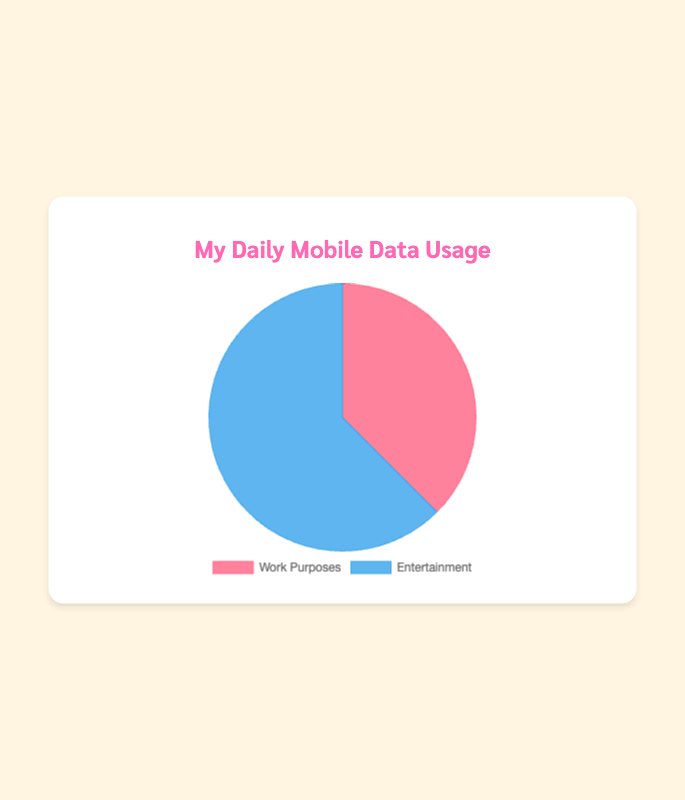What's the total average daily mobile data usage? Add the average data usage for both categories: Work Purposes (3000 MB) + Entertainment (5000 MB) = 8000 MB
Answer: 8000 MB Which category uses more mobile data daily, Work Purposes or Entertainment? Compare the average daily mobile data usage of each category: Work Purposes (3000 MB) vs. Entertainment (5000 MB). Entertainment uses more data.
Answer: Entertainment What percentage of the total daily mobile data usage is dedicated to Work Purposes? Calculate the percentage: (3000 MB / 8000 MB) * 100 = 37.5%
Answer: 37.5% What is the difference in daily mobile data usage between Work Purposes and Entertainment? Subtract the average daily data usage of Work Purposes from Entertainment: 5000 MB - 3000 MB = 2000 MB
Answer: 2000 MB How many times greater is the data usage for Entertainment compared to Work Purposes? Divide the average data usage of Entertainment by that of Work Purposes: 5000 MB / 3000 MB ≈ 1.67 times
Answer: 1.67 times Which category is represented by the blue color in the pie chart? Identify the color attributed to each category: Entertainment is represented by the blue color.
Answer: Entertainment What fraction of the pie chart is taken up by data for Work Purposes? Convert the percentage for Work Purposes into a fraction: 37.5% as a fraction is 3/8
Answer: 3/8 If the total daily mobile data usage increased by 20%, how much more data would be used for Work Purposes? Calculate 20% of 3000 MB: 0.2 * 3000 MB = 600 MB. Add this to the original: 3000 MB + 600 MB = 3600 MB
Answer: 600 MB If the average daily data usage of Netflix doubled, how would the total average daily mobile data usage change? Initially, Netflix uses 1500 MB. If doubled: 1500 MB * 2 = 3000 MB. Increase is: 3000 MB - 1500 MB = 1500 MB. New total: 8000 MB + 1500 MB = 9500 MB
Answer: 9500 MB What color represents Work Purposes in the pie chart? Identify the color represented in the pie chart: Work Purposes is represented by the red color.
Answer: Red 